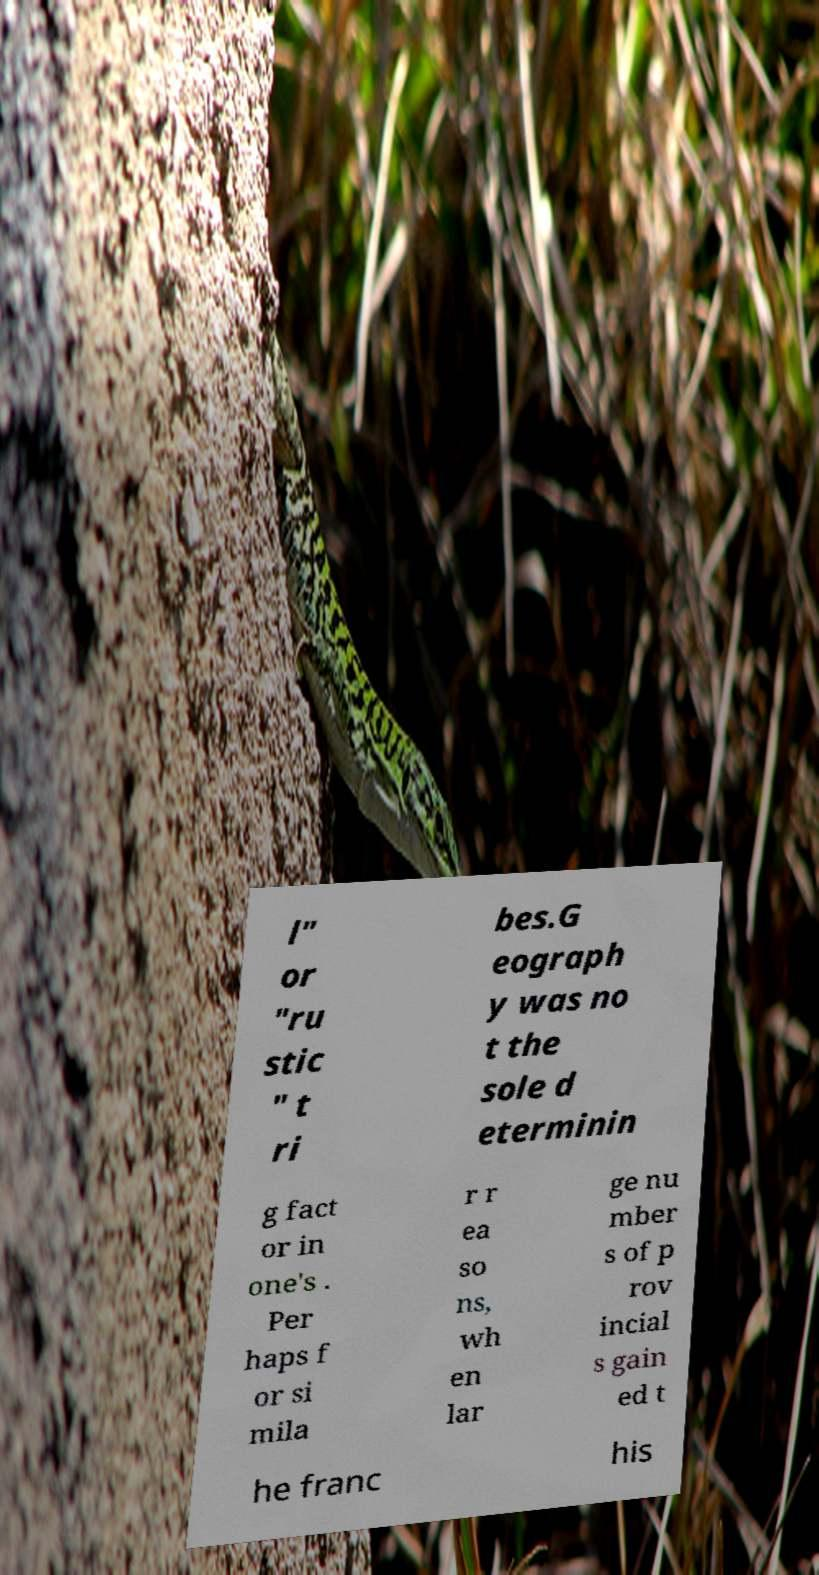Please identify and transcribe the text found in this image. l" or "ru stic " t ri bes.G eograph y was no t the sole d eterminin g fact or in one's . Per haps f or si mila r r ea so ns, wh en lar ge nu mber s of p rov incial s gain ed t he franc his 